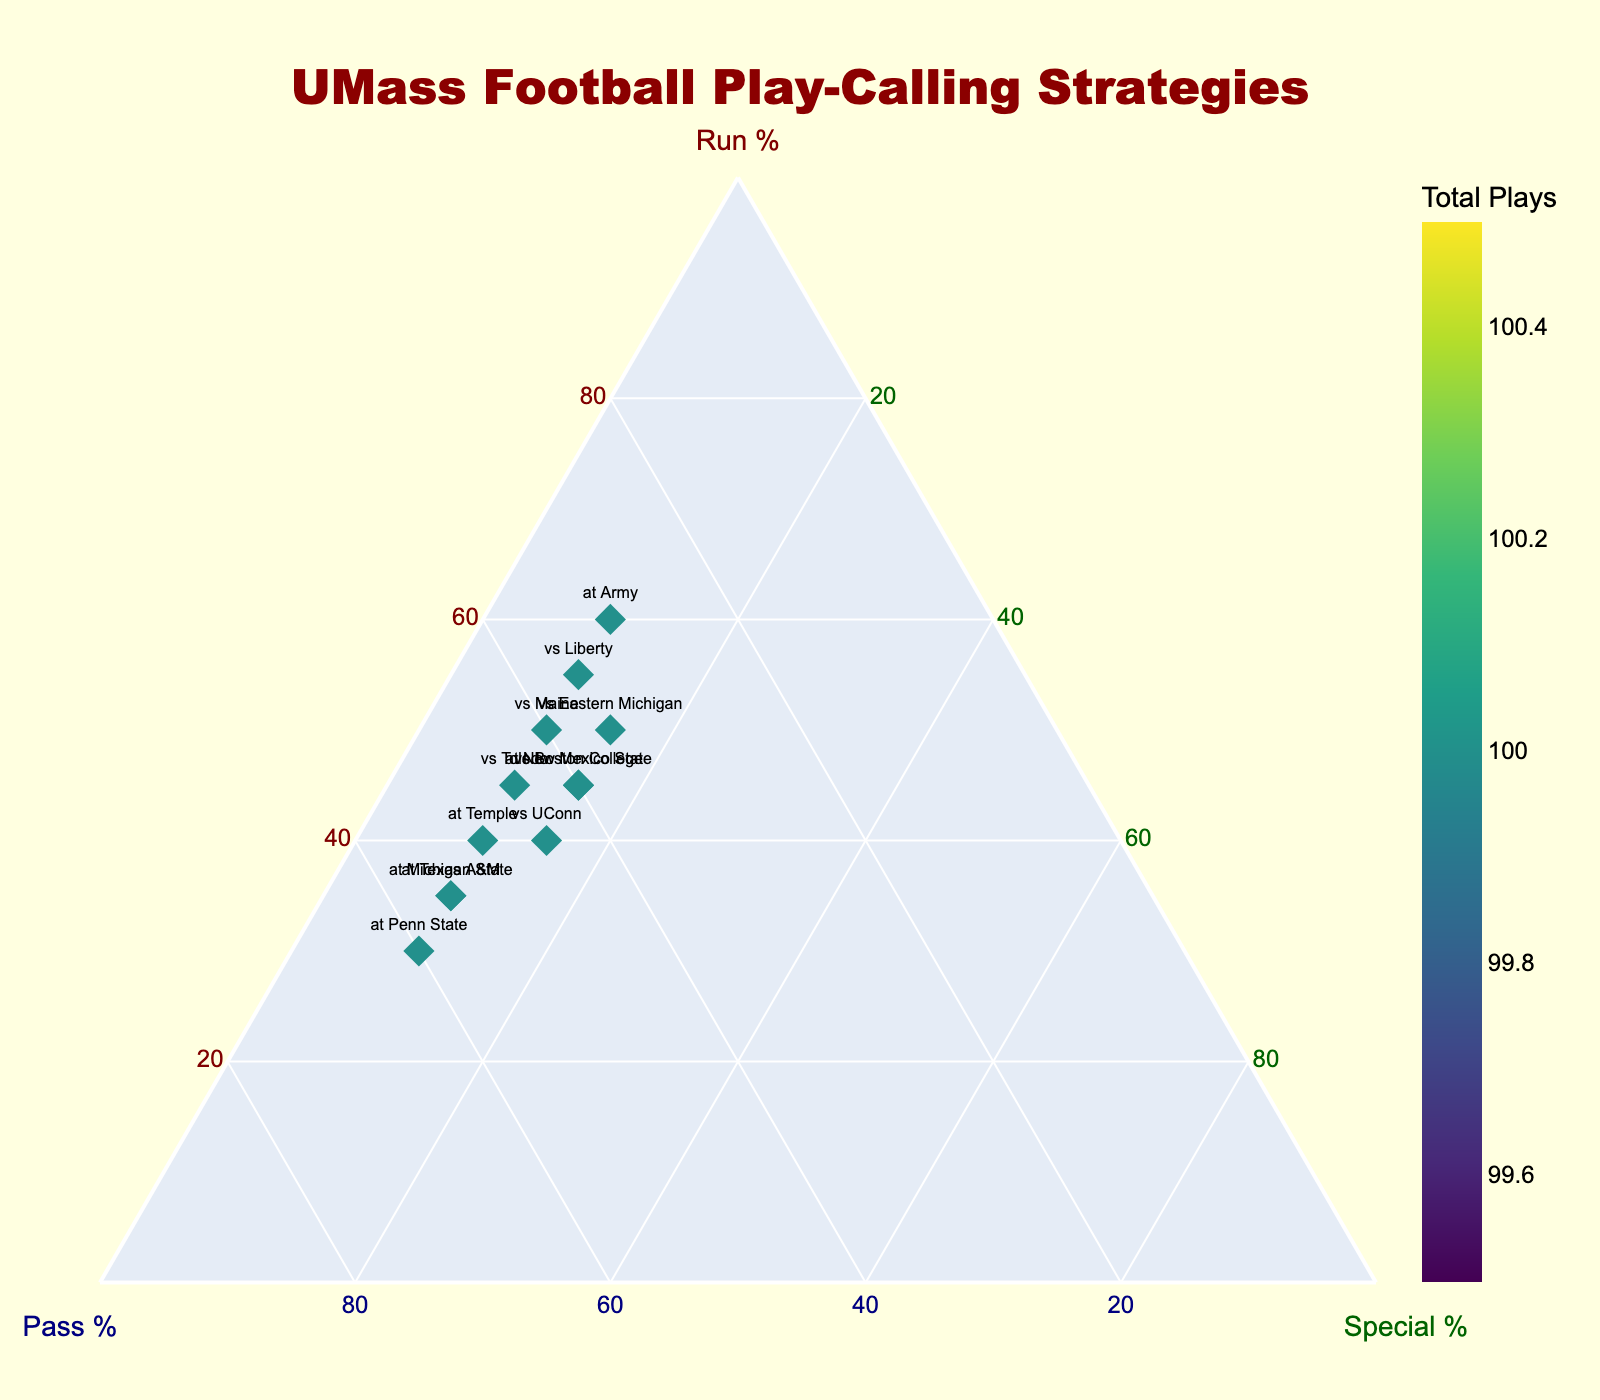What is the title of the figure? The title of the plot is usually located at the top of the figure. By reading it, one can understand the general topic or content of the plot.
Answer: UMass Football Play-Calling Strategies What is the percentage range for 'Run %' on the ternary plot? In a ternary plot, each axis typically represents a percentage ranging from a minimum to a maximum value. Here, the minimum and maximum are shown on the axis labels.
Answer: 0 to 100 Which game had the highest percentage of run plays? Each data point is labeled with a game and represented by its coordinates on the ternary plot. The game with the highest 'Run %' will be closest to the lower left corner of the triangle, where 'Run %' is at its maximum.
Answer: at Army Which game had the most balanced play-calling strategy (similar percentages of run, pass, and special)? A balanced play-calling strategy means that the data point would be closest to the center of the ternary plot, where 'Run %', 'Pass %', and 'Special %' are each roughly equal.
Answer: vs Boston College Compare the game vs Liberty and at Penn State. Which had a higher percentage of pass plays? Locate the positions of 'vs Liberty' and 'at Penn State' on the ternary plot. The game closer to the lower right corner indicates a higher 'Pass %'.
Answer: at Penn State How many total plays were in the game at New Mexico State? The color intensity on the markers represents the total number of plays. By observing the color scale used, the total number of plays for a particular game can be inferred.
Answer: 100 What does the color of the markers represent in the plot? Examining the color scale and legend on the plot helps understand what the marker color indicates. In this case, the color gradient is likely labeled appropriately.
Answer: Total Plays Which game had the highest percentage of special team plays? Locate the game closest to the top corner of the ternary plot, where 'Special %' peaks. This game's label will indicate the highest percentage of special team plays.
Answer: vs Boston College Are there more games with over 60% run plays or games with over 60% pass plays? Count the number of data points positioned closer to the lower left corner (indicating >60% 'Run %') and those near the lower right corner (indicating >60% 'Pass %').
Answer: Over 60% pass plays What can you infer about UMass' play-calling strategy against stronger opponents (e.g., Michigan State and Penn State)? Identify the data points for games against stronger opponents and examine their positions on the ternary plot to identify play-calling tendencies (e.g., more pass plays).
Answer: More pass plays 